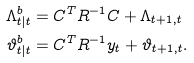<formula> <loc_0><loc_0><loc_500><loc_500>\Lambda ^ { b } _ { t | t } & = C ^ { T } R ^ { - 1 } C + \Lambda _ { t + 1 , t } \\ \vartheta ^ { b } _ { t | t } & = C ^ { T } R ^ { - 1 } y _ { t } + \vartheta _ { t + 1 , t } .</formula> 